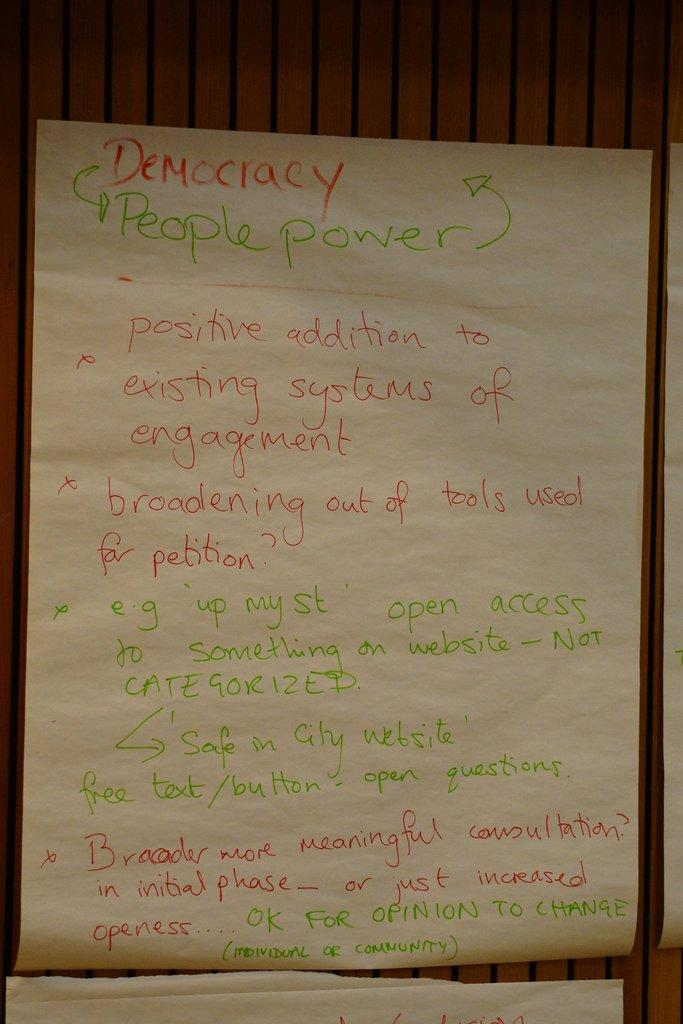<image>
Render a clear and concise summary of the photo. A piece of paper with notes about Democracy written in red and green. 